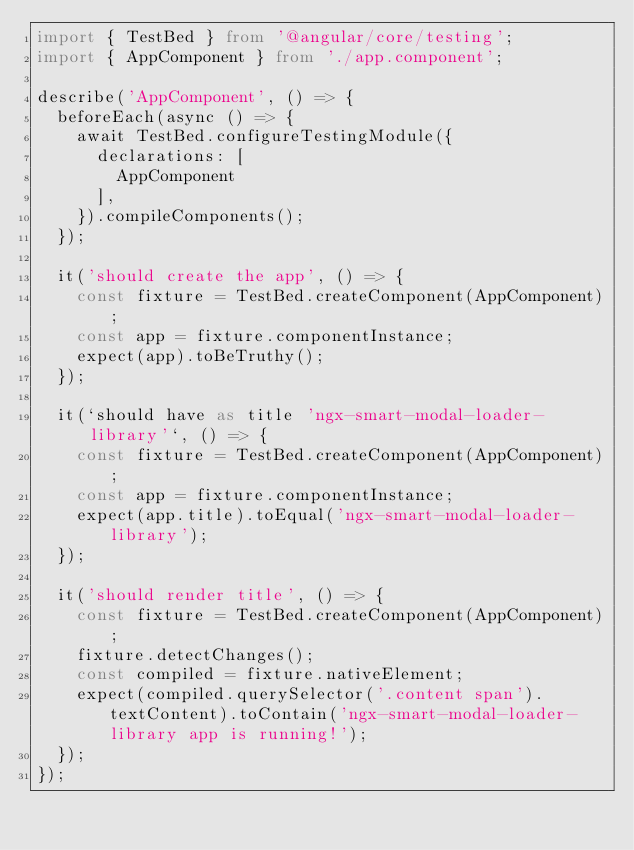Convert code to text. <code><loc_0><loc_0><loc_500><loc_500><_TypeScript_>import { TestBed } from '@angular/core/testing';
import { AppComponent } from './app.component';

describe('AppComponent', () => {
  beforeEach(async () => {
    await TestBed.configureTestingModule({
      declarations: [
        AppComponent
      ],
    }).compileComponents();
  });

  it('should create the app', () => {
    const fixture = TestBed.createComponent(AppComponent);
    const app = fixture.componentInstance;
    expect(app).toBeTruthy();
  });

  it(`should have as title 'ngx-smart-modal-loader-library'`, () => {
    const fixture = TestBed.createComponent(AppComponent);
    const app = fixture.componentInstance;
    expect(app.title).toEqual('ngx-smart-modal-loader-library');
  });

  it('should render title', () => {
    const fixture = TestBed.createComponent(AppComponent);
    fixture.detectChanges();
    const compiled = fixture.nativeElement;
    expect(compiled.querySelector('.content span').textContent).toContain('ngx-smart-modal-loader-library app is running!');
  });
});
</code> 